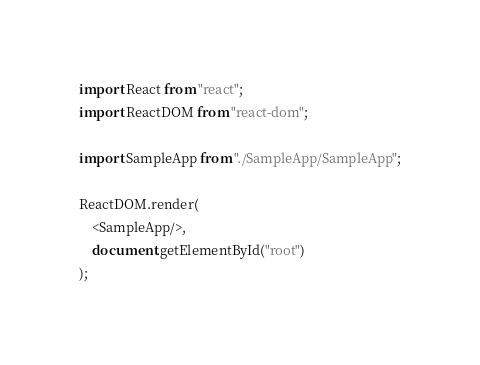<code> <loc_0><loc_0><loc_500><loc_500><_TypeScript_>import React from "react";
import ReactDOM from "react-dom";

import SampleApp from "./SampleApp/SampleApp";

ReactDOM.render(
    <SampleApp/>,
    document.getElementById("root")
);
</code> 